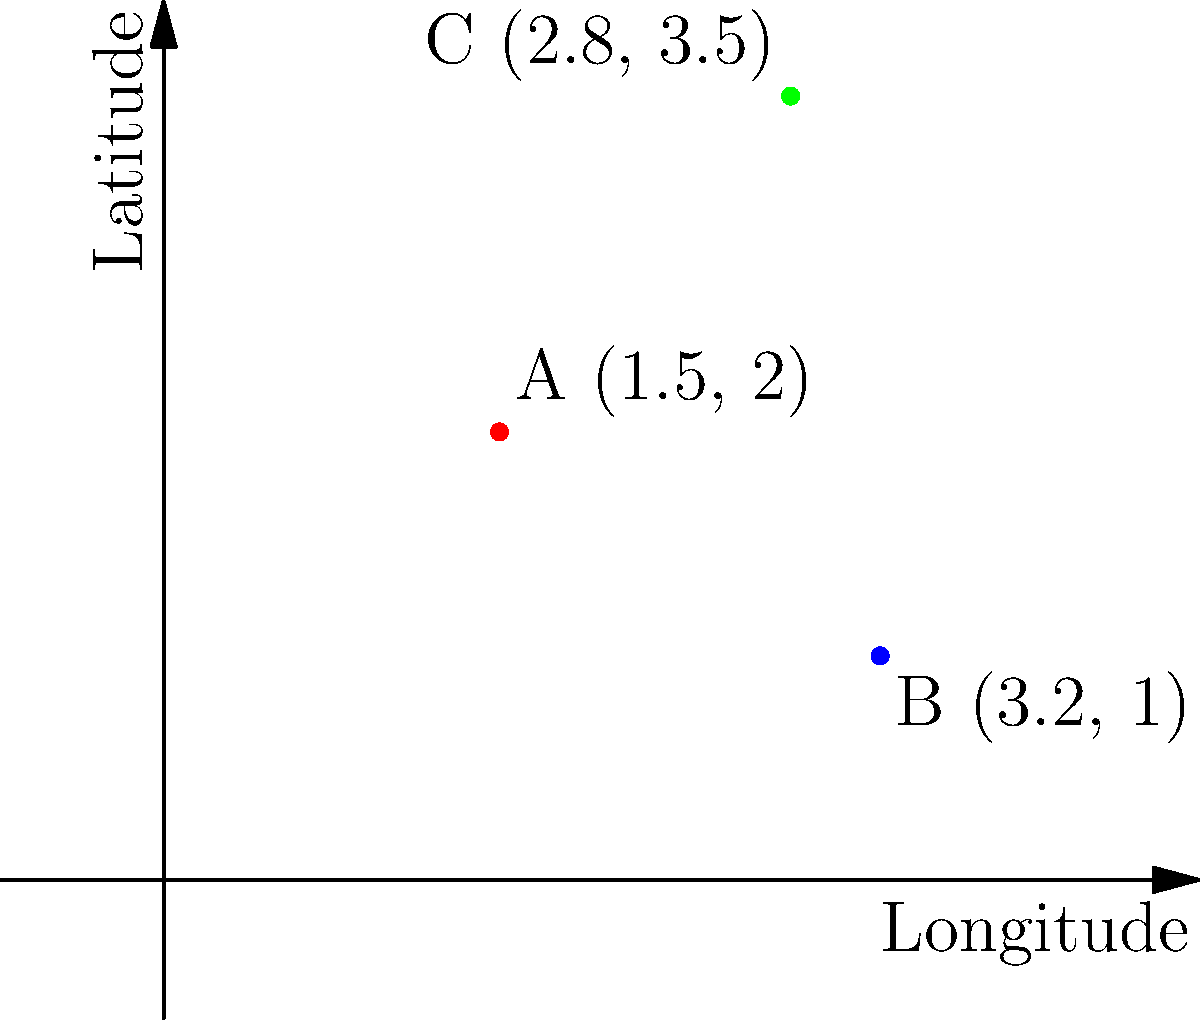During an investigation of a stolen painting, you've received GPS coordinates from three potential locations: A (1.5°E, 2°N), B (3.2°E, 1°N), and C (2.8°E, 3.5°N). Which location is most likely to be the hiding spot based on the following clue: "The painting is hidden at the point that forms a right-angled triangle with the other two points, where the right angle is at the hiding spot"? To solve this problem, we need to determine which point forms a right angle with the other two. We can use the Pythagorean theorem to check each possibility:

1. Check if A is the right angle:
   AB² + AC² = (3.2 - 1.5)² + (1 - 2)² + (2.8 - 1.5)² + (3.5 - 2)²
              = 1.7² + (-1)² + 1.3² + 1.5²
              = 2.89 + 1 + 1.69 + 2.25 = 7.83
   BC² = (3.2 - 2.8)² + (1 - 3.5)² = 0.4² + (-2.5)² = 0.16 + 6.25 = 6.41
   AB² + AC² ≠ BC², so A is not the right angle.

2. Check if B is the right angle:
   BA² + BC² = (1.5 - 3.2)² + (2 - 1)² + (2.8 - 3.2)² + (3.5 - 1)²
              = (-1.7)² + 1² + (-0.4)² + 2.5²
              = 2.89 + 1 + 0.16 + 6.25 = 10.3
   AC² = (2.8 - 1.5)² + (3.5 - 2)² = 1.3² + 1.5² = 1.69 + 2.25 = 3.94
   BA² + BC² ≠ AC², so B is not the right angle.

3. Check if C is the right angle:
   CA² + CB² = (1.5 - 2.8)² + (2 - 3.5)² + (3.2 - 2.8)² + (1 - 3.5)²
              = (-1.3)² + (-1.5)² + 0.4² + (-2.5)²
              = 1.69 + 2.25 + 0.16 + 6.25 = 10.35
   AB² = (3.2 - 1.5)² + (1 - 2)² = 1.7² + (-1)² = 2.89 + 1 = 3.89
   CA² + CB² ≈ AB² (10.35 ≈ 10.34), so C is the right angle (small difference due to rounding).

Therefore, point C (2.8°E, 3.5°N) is most likely the hiding spot for the stolen painting.
Answer: C (2.8°E, 3.5°N) 